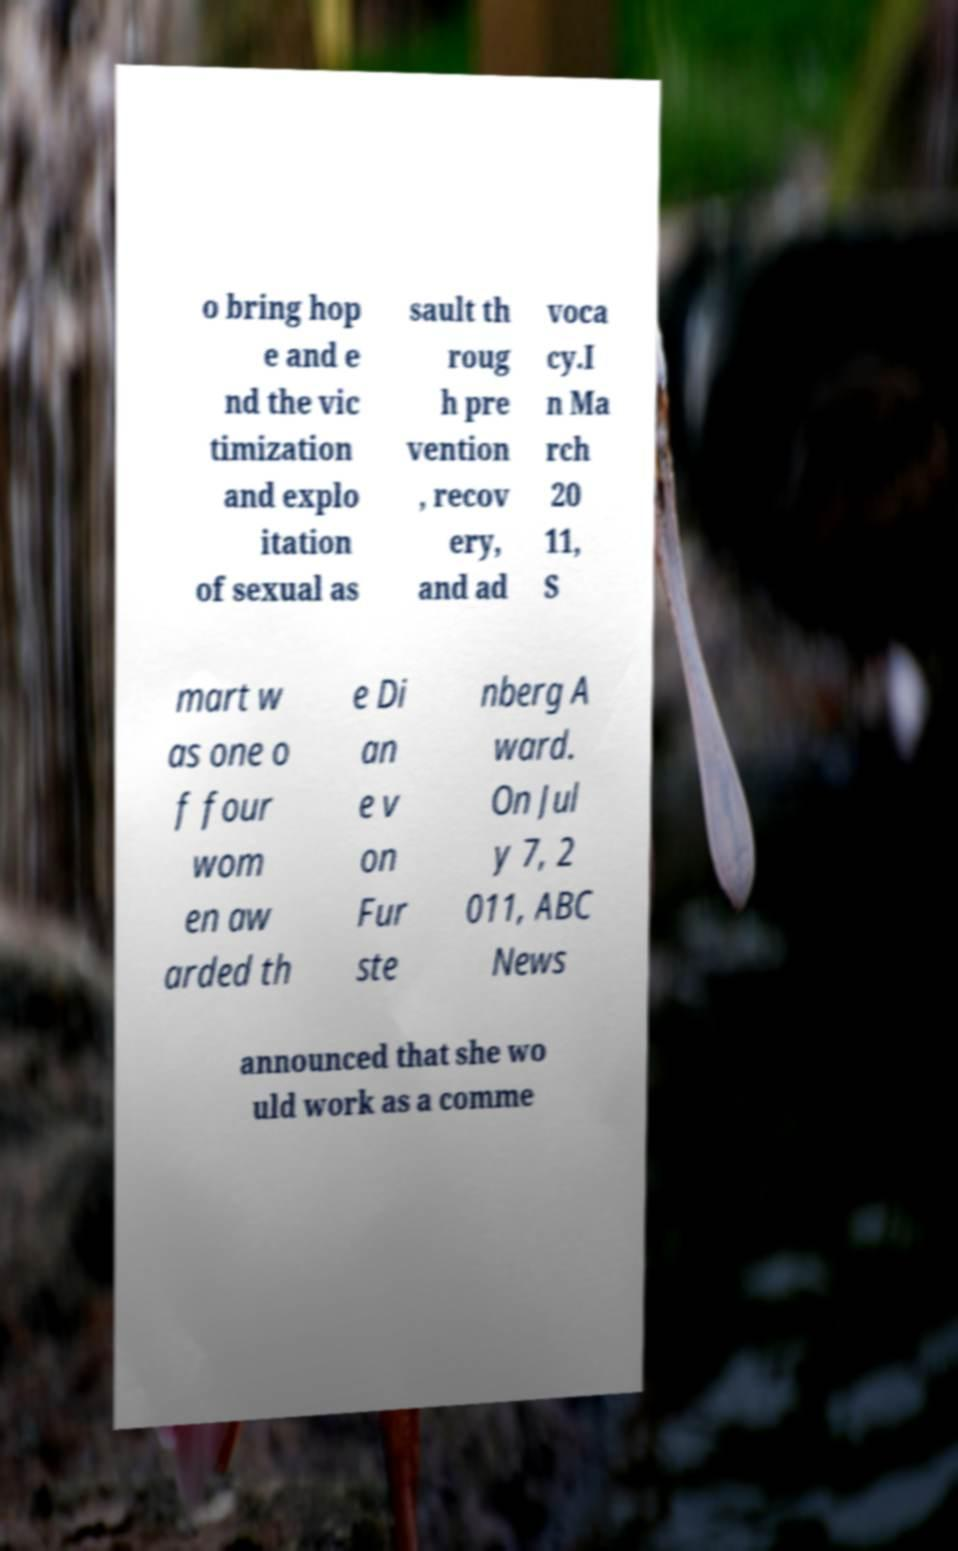Can you accurately transcribe the text from the provided image for me? o bring hop e and e nd the vic timization and explo itation of sexual as sault th roug h pre vention , recov ery, and ad voca cy.I n Ma rch 20 11, S mart w as one o f four wom en aw arded th e Di an e v on Fur ste nberg A ward. On Jul y 7, 2 011, ABC News announced that she wo uld work as a comme 